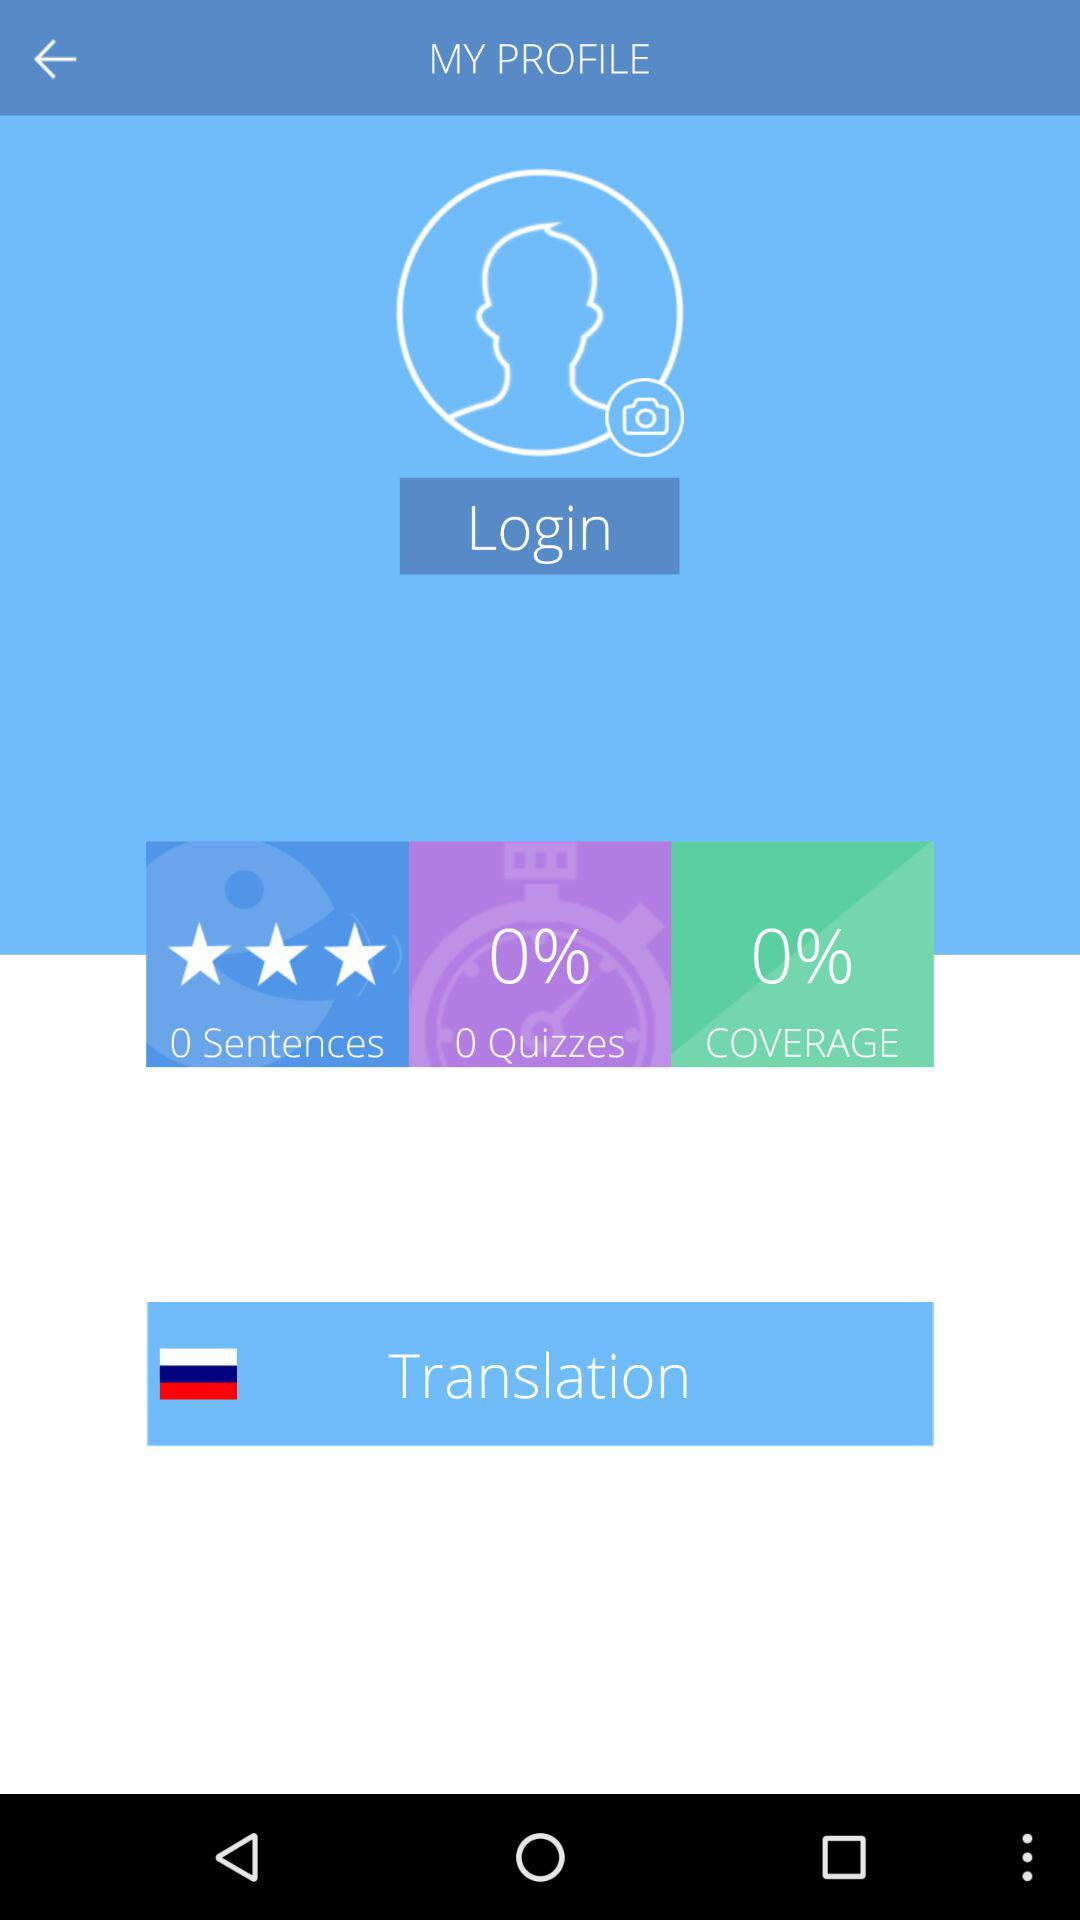What is the number of sentences? The number of sentences is 0. 